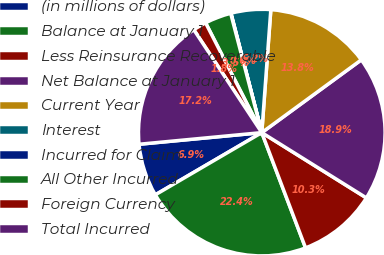<chart> <loc_0><loc_0><loc_500><loc_500><pie_chart><fcel>(in millions of dollars)<fcel>Balance at January 1<fcel>Less Reinsurance Recoverable<fcel>Net Balance at January 1<fcel>Current Year<fcel>Interest<fcel>Incurred for Claim<fcel>All Other Incurred<fcel>Foreign Currency<fcel>Total Incurred<nl><fcel>6.91%<fcel>22.36%<fcel>10.34%<fcel>18.93%<fcel>13.78%<fcel>5.19%<fcel>0.04%<fcel>3.47%<fcel>1.76%<fcel>17.21%<nl></chart> 